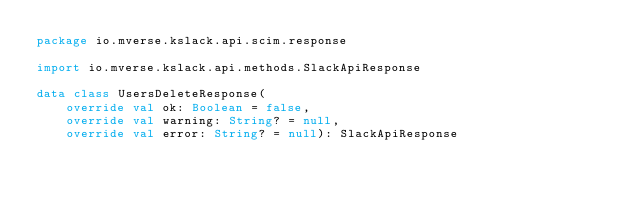<code> <loc_0><loc_0><loc_500><loc_500><_Kotlin_>package io.mverse.kslack.api.scim.response

import io.mverse.kslack.api.methods.SlackApiResponse

data class UsersDeleteResponse(
    override val ok: Boolean = false,
    override val warning: String? = null,
    override val error: String? = null): SlackApiResponse
</code> 